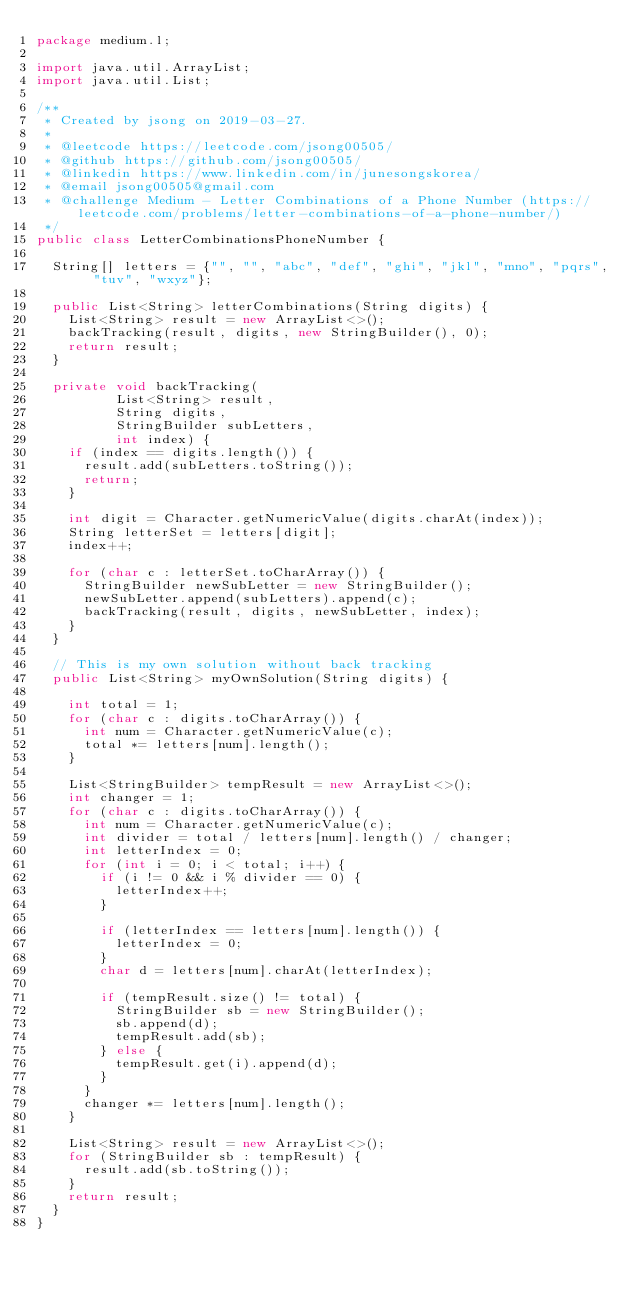Convert code to text. <code><loc_0><loc_0><loc_500><loc_500><_Java_>package medium.l;

import java.util.ArrayList;
import java.util.List;

/**
 * Created by jsong on 2019-03-27.
 *
 * @leetcode https://leetcode.com/jsong00505/
 * @github https://github.com/jsong00505/
 * @linkedin https://www.linkedin.com/in/junesongskorea/
 * @email jsong00505@gmail.com
 * @challenge Medium - Letter Combinations of a Phone Number (https://leetcode.com/problems/letter-combinations-of-a-phone-number/)
 */
public class LetterCombinationsPhoneNumber {

  String[] letters = {"", "", "abc", "def", "ghi", "jkl", "mno", "pqrs", "tuv", "wxyz"};

  public List<String> letterCombinations(String digits) {
    List<String> result = new ArrayList<>();
    backTracking(result, digits, new StringBuilder(), 0);
    return result;
  }

  private void backTracking(
          List<String> result,
          String digits,
          StringBuilder subLetters,
          int index) {
    if (index == digits.length()) {
      result.add(subLetters.toString());
      return;
    }

    int digit = Character.getNumericValue(digits.charAt(index));
    String letterSet = letters[digit];
    index++;

    for (char c : letterSet.toCharArray()) {
      StringBuilder newSubLetter = new StringBuilder();
      newSubLetter.append(subLetters).append(c);
      backTracking(result, digits, newSubLetter, index);
    }
  }

  // This is my own solution without back tracking
  public List<String> myOwnSolution(String digits) {

    int total = 1;
    for (char c : digits.toCharArray()) {
      int num = Character.getNumericValue(c);
      total *= letters[num].length();
    }

    List<StringBuilder> tempResult = new ArrayList<>();
    int changer = 1;
    for (char c : digits.toCharArray()) {
      int num = Character.getNumericValue(c);
      int divider = total / letters[num].length() / changer;
      int letterIndex = 0;
      for (int i = 0; i < total; i++) {
        if (i != 0 && i % divider == 0) {
          letterIndex++;
        }

        if (letterIndex == letters[num].length()) {
          letterIndex = 0;
        }
        char d = letters[num].charAt(letterIndex);

        if (tempResult.size() != total) {
          StringBuilder sb = new StringBuilder();
          sb.append(d);
          tempResult.add(sb);
        } else {
          tempResult.get(i).append(d);
        }
      }
      changer *= letters[num].length();
    }

    List<String> result = new ArrayList<>();
    for (StringBuilder sb : tempResult) {
      result.add(sb.toString());
    }
    return result;
  }
}</code> 